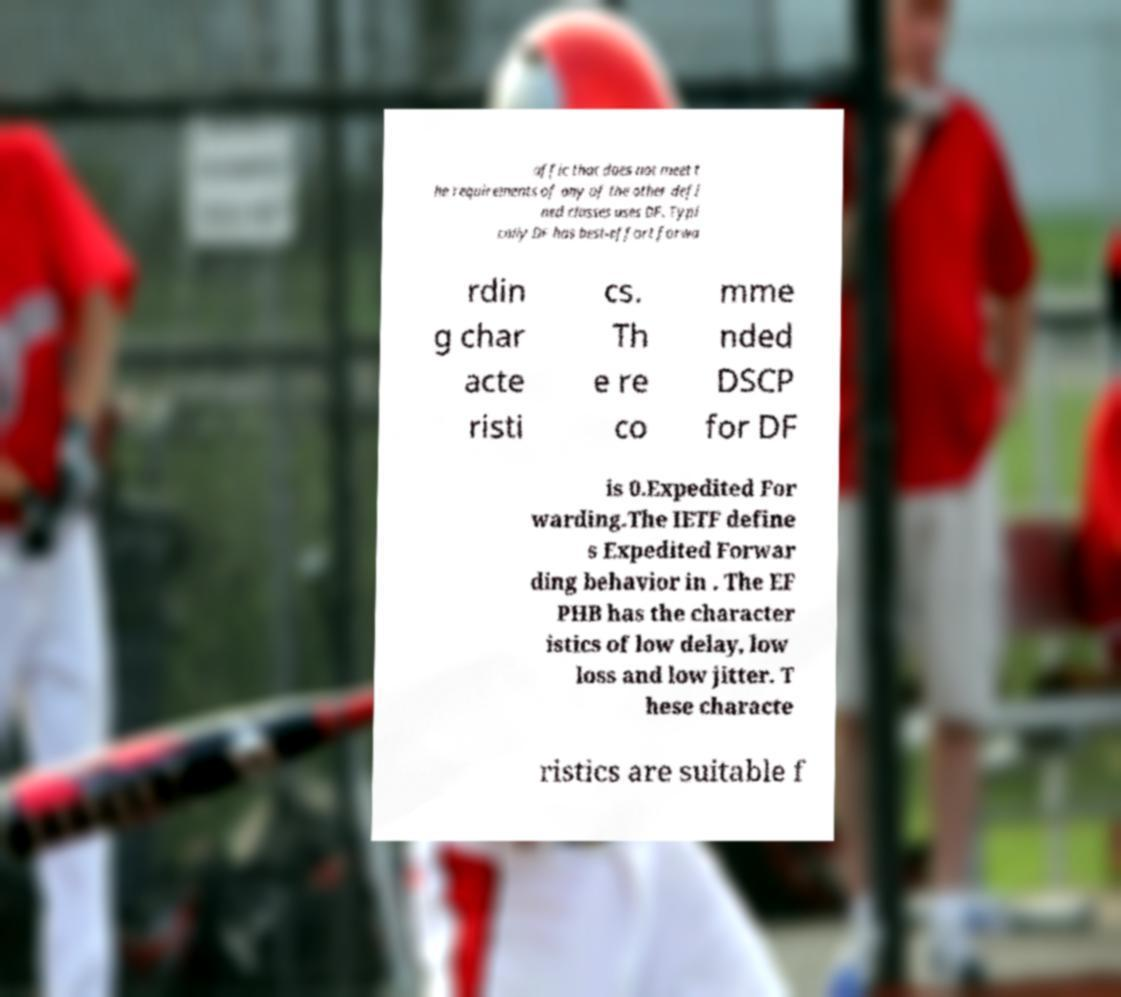Please read and relay the text visible in this image. What does it say? affic that does not meet t he requirements of any of the other defi ned classes uses DF. Typi cally DF has best-effort forwa rdin g char acte risti cs. Th e re co mme nded DSCP for DF is 0.Expedited For warding.The IETF define s Expedited Forwar ding behavior in . The EF PHB has the character istics of low delay, low loss and low jitter. T hese characte ristics are suitable f 